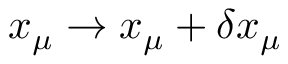Convert formula to latex. <formula><loc_0><loc_0><loc_500><loc_500>x _ { \mu } \rightarrow x _ { \mu } + \delta x _ { \mu }</formula> 